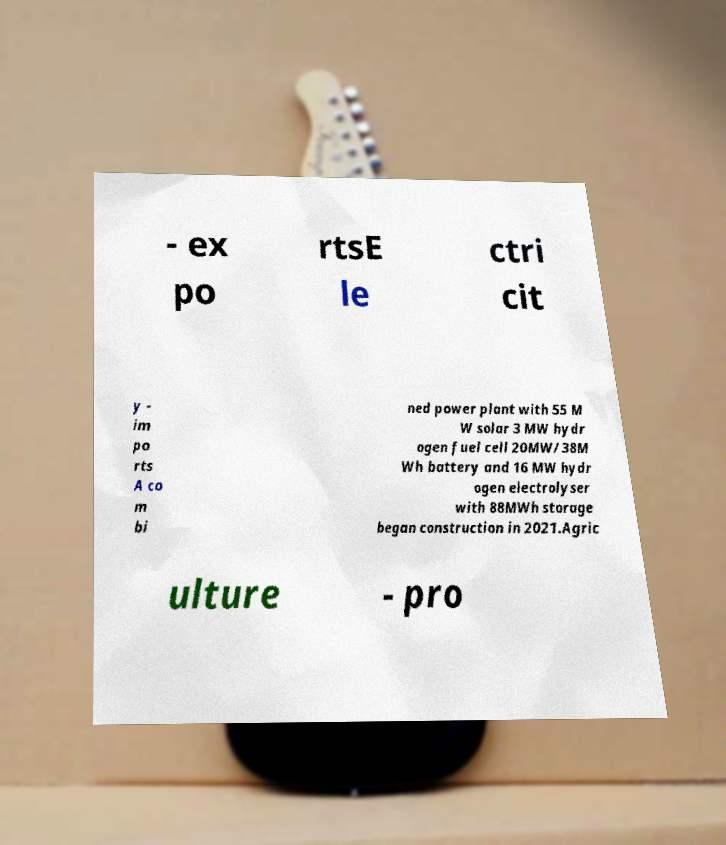What messages or text are displayed in this image? I need them in a readable, typed format. - ex po rtsE le ctri cit y - im po rts A co m bi ned power plant with 55 M W solar 3 MW hydr ogen fuel cell 20MW/38M Wh battery and 16 MW hydr ogen electrolyser with 88MWh storage began construction in 2021.Agric ulture - pro 